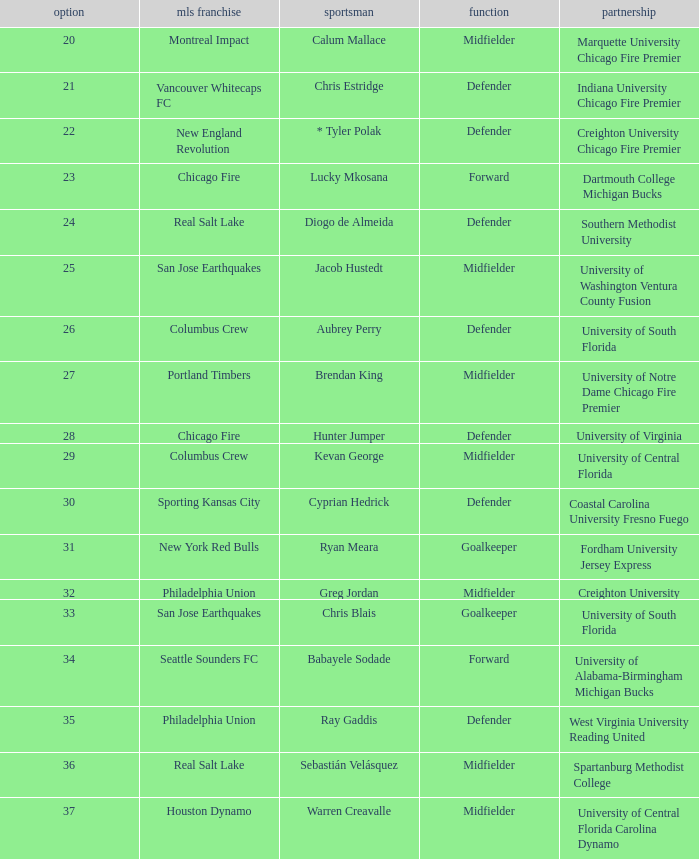What pick number did Real Salt Lake get? 24.0. 